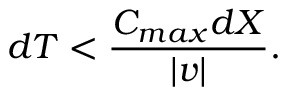<formula> <loc_0><loc_0><loc_500><loc_500>d T < \frac { C _ { \max } d X } { | v | } .</formula> 